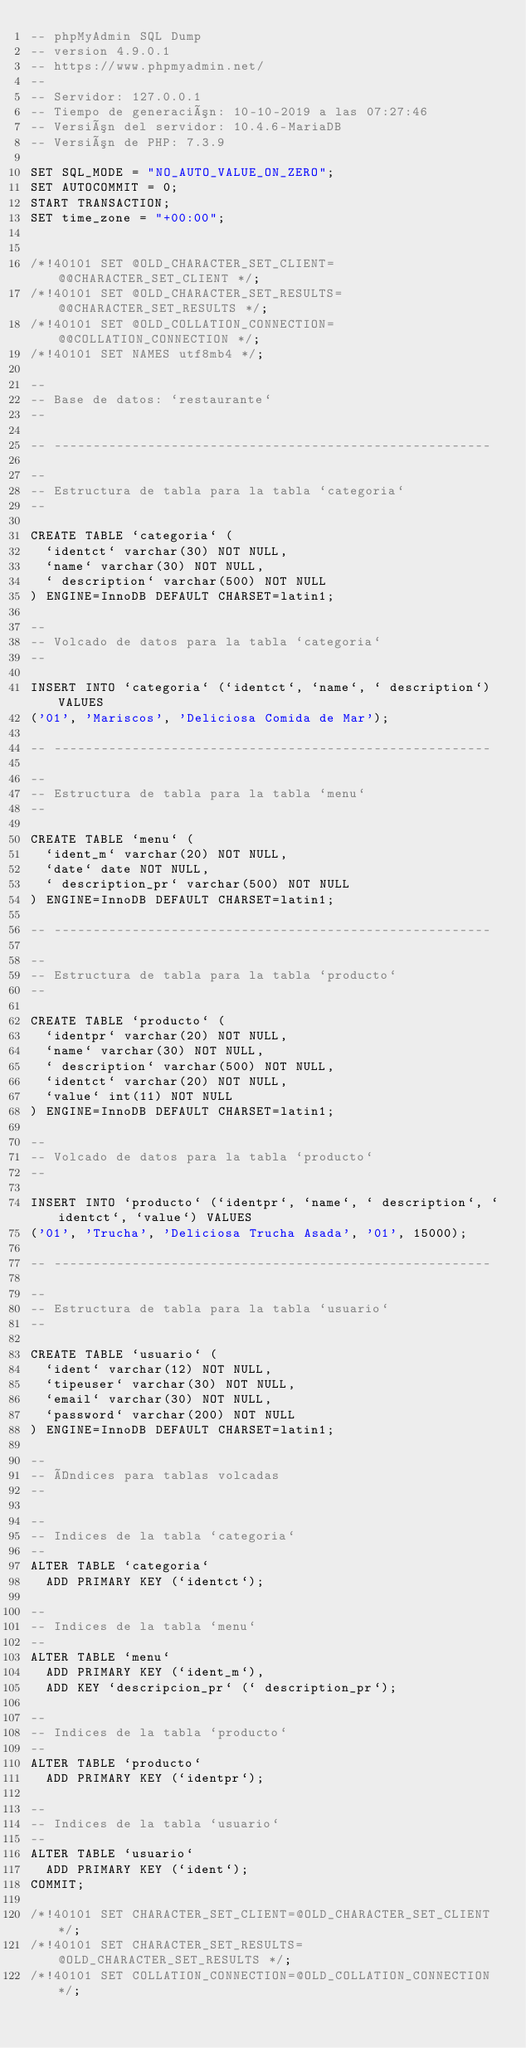<code> <loc_0><loc_0><loc_500><loc_500><_SQL_>-- phpMyAdmin SQL Dump
-- version 4.9.0.1
-- https://www.phpmyadmin.net/
--
-- Servidor: 127.0.0.1
-- Tiempo de generación: 10-10-2019 a las 07:27:46
-- Versión del servidor: 10.4.6-MariaDB
-- Versión de PHP: 7.3.9

SET SQL_MODE = "NO_AUTO_VALUE_ON_ZERO";
SET AUTOCOMMIT = 0;
START TRANSACTION;
SET time_zone = "+00:00";


/*!40101 SET @OLD_CHARACTER_SET_CLIENT=@@CHARACTER_SET_CLIENT */;
/*!40101 SET @OLD_CHARACTER_SET_RESULTS=@@CHARACTER_SET_RESULTS */;
/*!40101 SET @OLD_COLLATION_CONNECTION=@@COLLATION_CONNECTION */;
/*!40101 SET NAMES utf8mb4 */;

--
-- Base de datos: `restaurante`
--

-- --------------------------------------------------------

--
-- Estructura de tabla para la tabla `categoria`
--

CREATE TABLE `categoria` (
  `identct` varchar(30) NOT NULL,
  `name` varchar(30) NOT NULL,
  ` description` varchar(500) NOT NULL
) ENGINE=InnoDB DEFAULT CHARSET=latin1;

--
-- Volcado de datos para la tabla `categoria`
--

INSERT INTO `categoria` (`identct`, `name`, ` description`) VALUES
('01', 'Mariscos', 'Deliciosa Comida de Mar');

-- --------------------------------------------------------

--
-- Estructura de tabla para la tabla `menu`
--

CREATE TABLE `menu` (
  `ident_m` varchar(20) NOT NULL,
  `date` date NOT NULL,
  ` description_pr` varchar(500) NOT NULL
) ENGINE=InnoDB DEFAULT CHARSET=latin1;

-- --------------------------------------------------------

--
-- Estructura de tabla para la tabla `producto`
--

CREATE TABLE `producto` (
  `identpr` varchar(20) NOT NULL,
  `name` varchar(30) NOT NULL,
  ` description` varchar(500) NOT NULL,
  `identct` varchar(20) NOT NULL,
  `value` int(11) NOT NULL
) ENGINE=InnoDB DEFAULT CHARSET=latin1;

--
-- Volcado de datos para la tabla `producto`
--

INSERT INTO `producto` (`identpr`, `name`, ` description`, `identct`, `value`) VALUES
('01', 'Trucha', 'Deliciosa Trucha Asada', '01', 15000);

-- --------------------------------------------------------

--
-- Estructura de tabla para la tabla `usuario`
--

CREATE TABLE `usuario` (
  `ident` varchar(12) NOT NULL,
  `tipeuser` varchar(30) NOT NULL,
  `email` varchar(30) NOT NULL,
  `password` varchar(200) NOT NULL
) ENGINE=InnoDB DEFAULT CHARSET=latin1;

--
-- Índices para tablas volcadas
--

--
-- Indices de la tabla `categoria`
--
ALTER TABLE `categoria`
  ADD PRIMARY KEY (`identct`);

--
-- Indices de la tabla `menu`
--
ALTER TABLE `menu`
  ADD PRIMARY KEY (`ident_m`),
  ADD KEY `descripcion_pr` (` description_pr`);

--
-- Indices de la tabla `producto`
--
ALTER TABLE `producto`
  ADD PRIMARY KEY (`identpr`);

--
-- Indices de la tabla `usuario`
--
ALTER TABLE `usuario`
  ADD PRIMARY KEY (`ident`);
COMMIT;

/*!40101 SET CHARACTER_SET_CLIENT=@OLD_CHARACTER_SET_CLIENT */;
/*!40101 SET CHARACTER_SET_RESULTS=@OLD_CHARACTER_SET_RESULTS */;
/*!40101 SET COLLATION_CONNECTION=@OLD_COLLATION_CONNECTION */;
</code> 